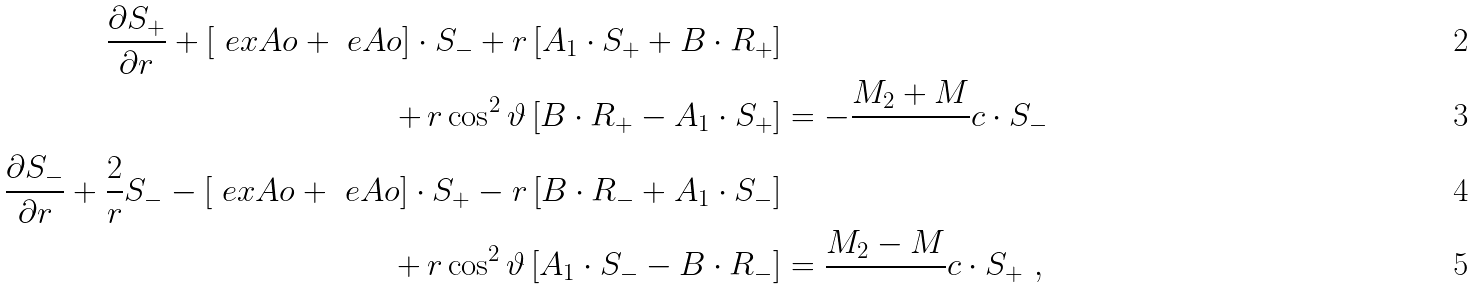<formula> <loc_0><loc_0><loc_500><loc_500>\frac { \partial S _ { + } } { \partial r } + \left [ \ e x A o + \ e A o \right ] \cdot S _ { - } + r \left [ A _ { 1 } \cdot S _ { + } + B \cdot R _ { + } \right ] & \\ + \, r \cos ^ { 2 } \vartheta \left [ B \cdot R _ { + } - A _ { 1 } \cdot S _ { + } \right ] & = - \frac { M _ { 2 } + M } { } c \cdot S _ { - } \\ \frac { \partial S _ { - } } { \partial r } + \frac { 2 } { r } S _ { - } - \left [ \ e x A o + \ e A o \right ] \cdot S _ { + } - r \left [ B \cdot R _ { - } + A _ { 1 } \cdot S _ { - } \right ] & \\ + \, r \cos ^ { 2 } \vartheta \left [ A _ { 1 } \cdot S _ { - } - B \cdot R _ { - } \right ] & = \frac { M _ { 2 } - M } { } c \cdot S _ { + } \ ,</formula> 